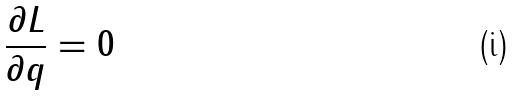Convert formula to latex. <formula><loc_0><loc_0><loc_500><loc_500>\frac { \partial L } { \partial q } = 0</formula> 